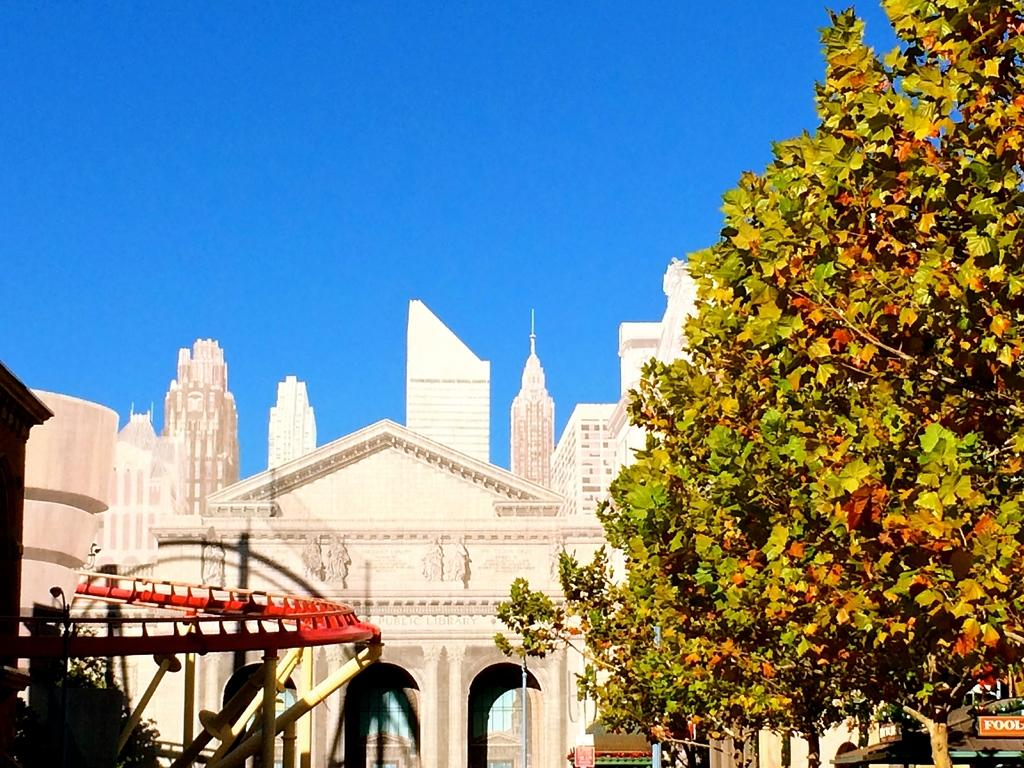What type of natural elements can be seen in the image? There are trees in the image. What type of man-made structures are visible in the image? There are buildings in the image. What part of the natural environment is visible in the image? The sky is visible in the image. What type of text or writing is present in the image? There is text or writing present in the image. What type of expert can be seen in the image? There is no expert present in the image; it features trees, buildings, the sky, and text or writing. What time of day is depicted in the image? The provided facts do not specify the time of day, so it cannot be determined from the image. 